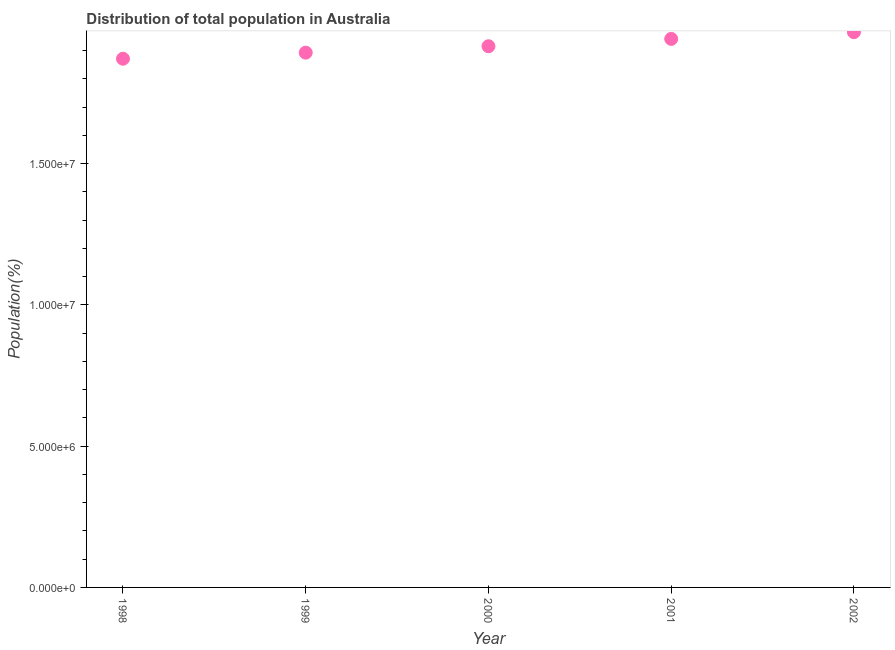What is the population in 2001?
Offer a very short reply. 1.94e+07. Across all years, what is the maximum population?
Offer a terse response. 1.97e+07. Across all years, what is the minimum population?
Your answer should be compact. 1.87e+07. What is the sum of the population?
Provide a succinct answer. 9.59e+07. What is the difference between the population in 2000 and 2002?
Offer a very short reply. -4.98e+05. What is the average population per year?
Keep it short and to the point. 1.92e+07. What is the median population?
Your response must be concise. 1.92e+07. What is the ratio of the population in 1998 to that in 2000?
Provide a short and direct response. 0.98. Is the difference between the population in 1999 and 2001 greater than the difference between any two years?
Your answer should be very brief. No. What is the difference between the highest and the second highest population?
Your response must be concise. 2.38e+05. What is the difference between the highest and the lowest population?
Your response must be concise. 9.40e+05. In how many years, is the population greater than the average population taken over all years?
Your answer should be very brief. 2. How many years are there in the graph?
Give a very brief answer. 5. What is the title of the graph?
Offer a terse response. Distribution of total population in Australia . What is the label or title of the Y-axis?
Provide a succinct answer. Population(%). What is the Population(%) in 1998?
Give a very brief answer. 1.87e+07. What is the Population(%) in 1999?
Your answer should be compact. 1.89e+07. What is the Population(%) in 2000?
Your answer should be compact. 1.92e+07. What is the Population(%) in 2001?
Keep it short and to the point. 1.94e+07. What is the Population(%) in 2002?
Provide a succinct answer. 1.97e+07. What is the difference between the Population(%) in 1998 and 1999?
Provide a short and direct response. -2.15e+05. What is the difference between the Population(%) in 1998 and 2000?
Your answer should be compact. -4.42e+05. What is the difference between the Population(%) in 1998 and 2001?
Provide a short and direct response. -7.02e+05. What is the difference between the Population(%) in 1998 and 2002?
Your answer should be compact. -9.40e+05. What is the difference between the Population(%) in 1999 and 2000?
Provide a short and direct response. -2.27e+05. What is the difference between the Population(%) in 1999 and 2001?
Your answer should be very brief. -4.87e+05. What is the difference between the Population(%) in 1999 and 2002?
Give a very brief answer. -7.25e+05. What is the difference between the Population(%) in 2000 and 2001?
Your response must be concise. -2.60e+05. What is the difference between the Population(%) in 2000 and 2002?
Your response must be concise. -4.98e+05. What is the difference between the Population(%) in 2001 and 2002?
Your answer should be very brief. -2.38e+05. What is the ratio of the Population(%) in 1998 to that in 1999?
Offer a terse response. 0.99. What is the ratio of the Population(%) in 1999 to that in 2000?
Your response must be concise. 0.99. What is the ratio of the Population(%) in 1999 to that in 2001?
Your answer should be very brief. 0.97. What is the ratio of the Population(%) in 2000 to that in 2002?
Your response must be concise. 0.97. What is the ratio of the Population(%) in 2001 to that in 2002?
Keep it short and to the point. 0.99. 